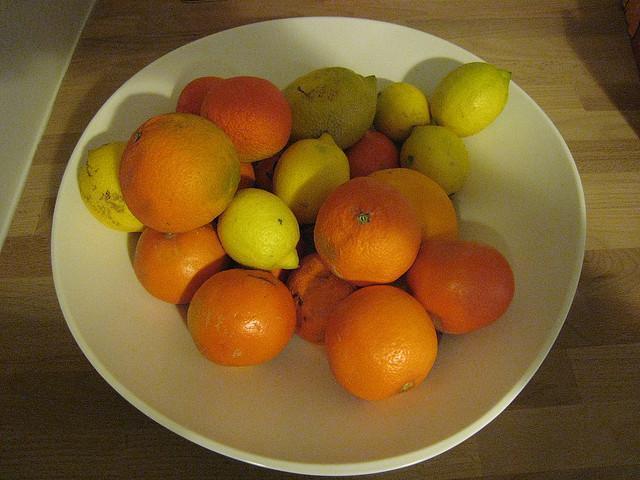How many different types of fruit are in the bowl?
Give a very brief answer. 2. How many oranges are in the picture?
Give a very brief answer. 9. How many women wearing a red dress complimented by black stockings are there?
Give a very brief answer. 0. 